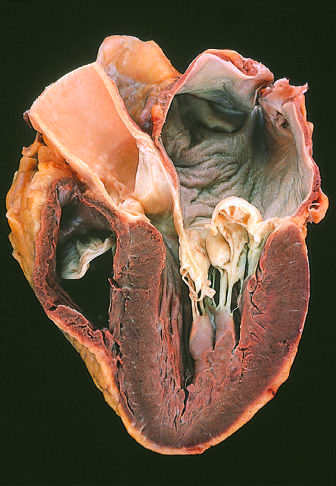what is dilated, reflecting long-standing valvular insufficiency and volume overload?
Answer the question using a single word or phrase. The atrium 